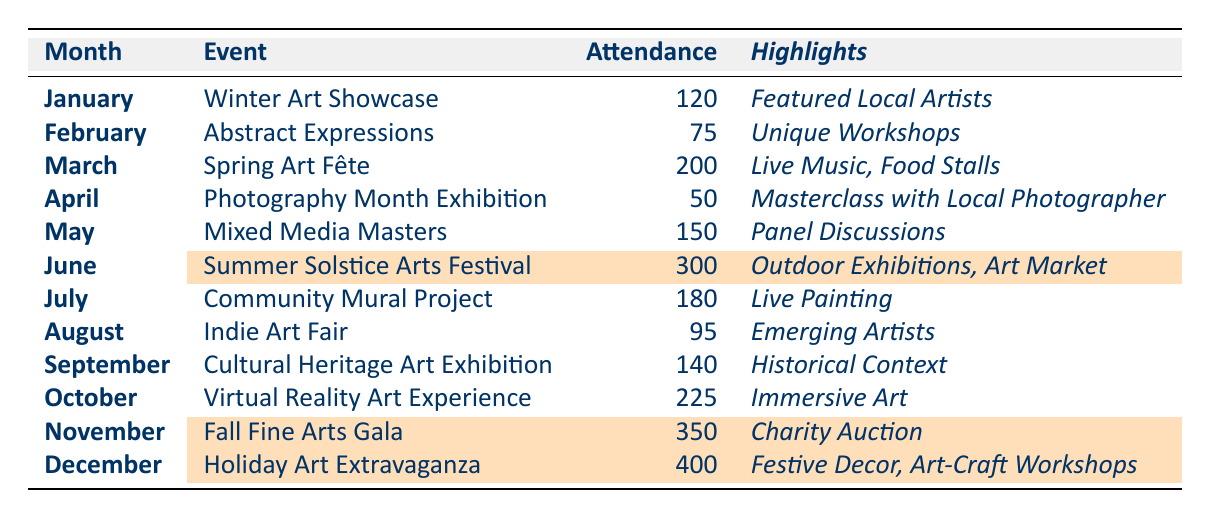What is the attendance for the "Mixed Media Masters" event? The table lists the event "Mixed Media Masters" in May 2023 with an attendance of 150.
Answer: 150 Which month had the highest attendance at an art event? According to the table, December 2023 had the highest attendance with the "Holiday Art Extravaganza" reaching 400 attendees.
Answer: December 2023 What is the total attendance for the art events held in the first quarter of 2023? The first quarter includes January (120), February (75), and March (200). Adding these gives: 120 + 75 + 200 = 395.
Answer: 395 Was the attendance for the "Summer Solstice Arts Festival" higher than the "Cultural Heritage Art Exhibition"? The "Summer Solstice Arts Festival" had 300 attendees, while the "Cultural Heritage Art Exhibition" had 140. Since 300 is greater than 140, the answer is yes.
Answer: Yes How many events had an attendance greater than 200? The events with attendance greater than 200 are "Summer Solstice Arts Festival" (300), "Fall Fine Arts Gala" (350), and "Holiday Art Extravaganza" (400). Counting these gives three events.
Answer: 3 What is the average attendance for events between March and September 2023? The events and their attendances from March to September are: March (200), April (50), May (150), June (300), July (180), August (95). Adding these gives: 200 + 50 + 150 + 300 + 180 + 95 = 975. There are 6 events, so the average is 975/6 = 162.5.
Answer: 162.5 Which event in November 2023 had a specific highlight related to charity? The event in November 2023 is the "Fall Fine Arts Gala," which has a highlight of "Charity Auction."
Answer: Fall Fine Arts Gala What percentage increase in attendance was there from the "Virtual Reality Art Experience" to the "Fall Fine Arts Gala"? The "Fall Fine Arts Gala" attendance is 350, and the "Virtual Reality Art Experience" is 225. The increase is 350 - 225 = 125. To find the percentage increase: (125 / 225) * 100 = 55.56%.
Answer: 55.56% Is it true that all events from June to December have an attendance exceeding 200? The events from June to December have the following attendances: June (300), July (180), August (95), September (140), October (225), November (350), December (400). Since July and August have attendances below 200, it is false.
Answer: No Which month’s event had the most engaging activities based on the number of highlights? The event in June, "Summer Solstice Arts Festival," had three highlights: Outdoor Exhibitions, Art Market, and Kids' Zone, which is the most compared to other months.
Answer: June 